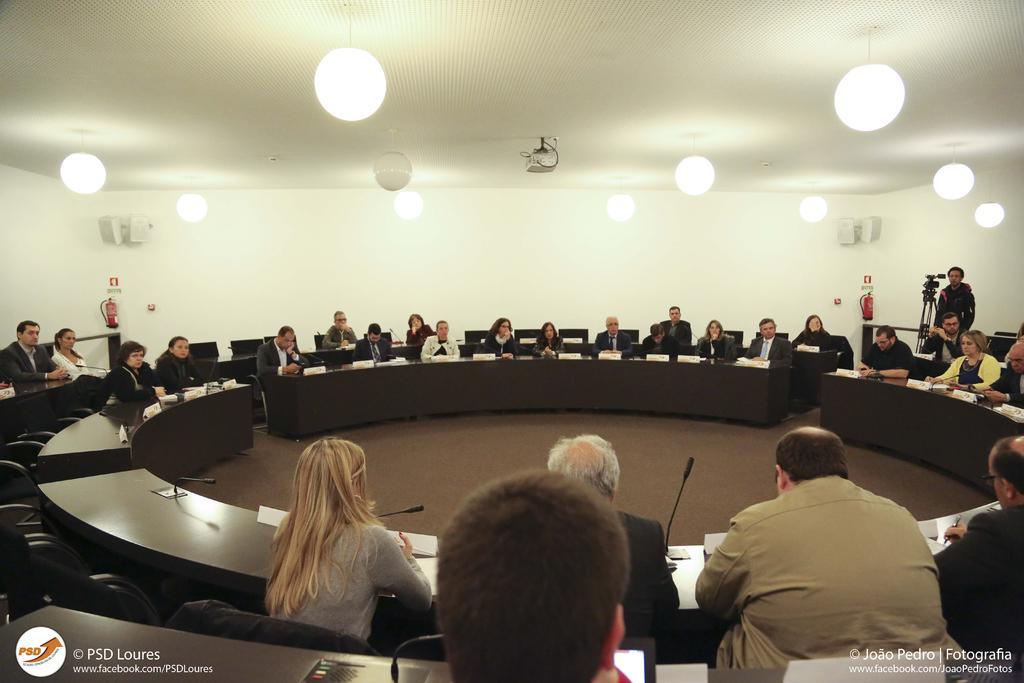Can you describe this image briefly? In this image there are persons sitting in front of the round table and on the right side there is a man standing, in front of the man there is a camera. On the top there are lights hanging. 